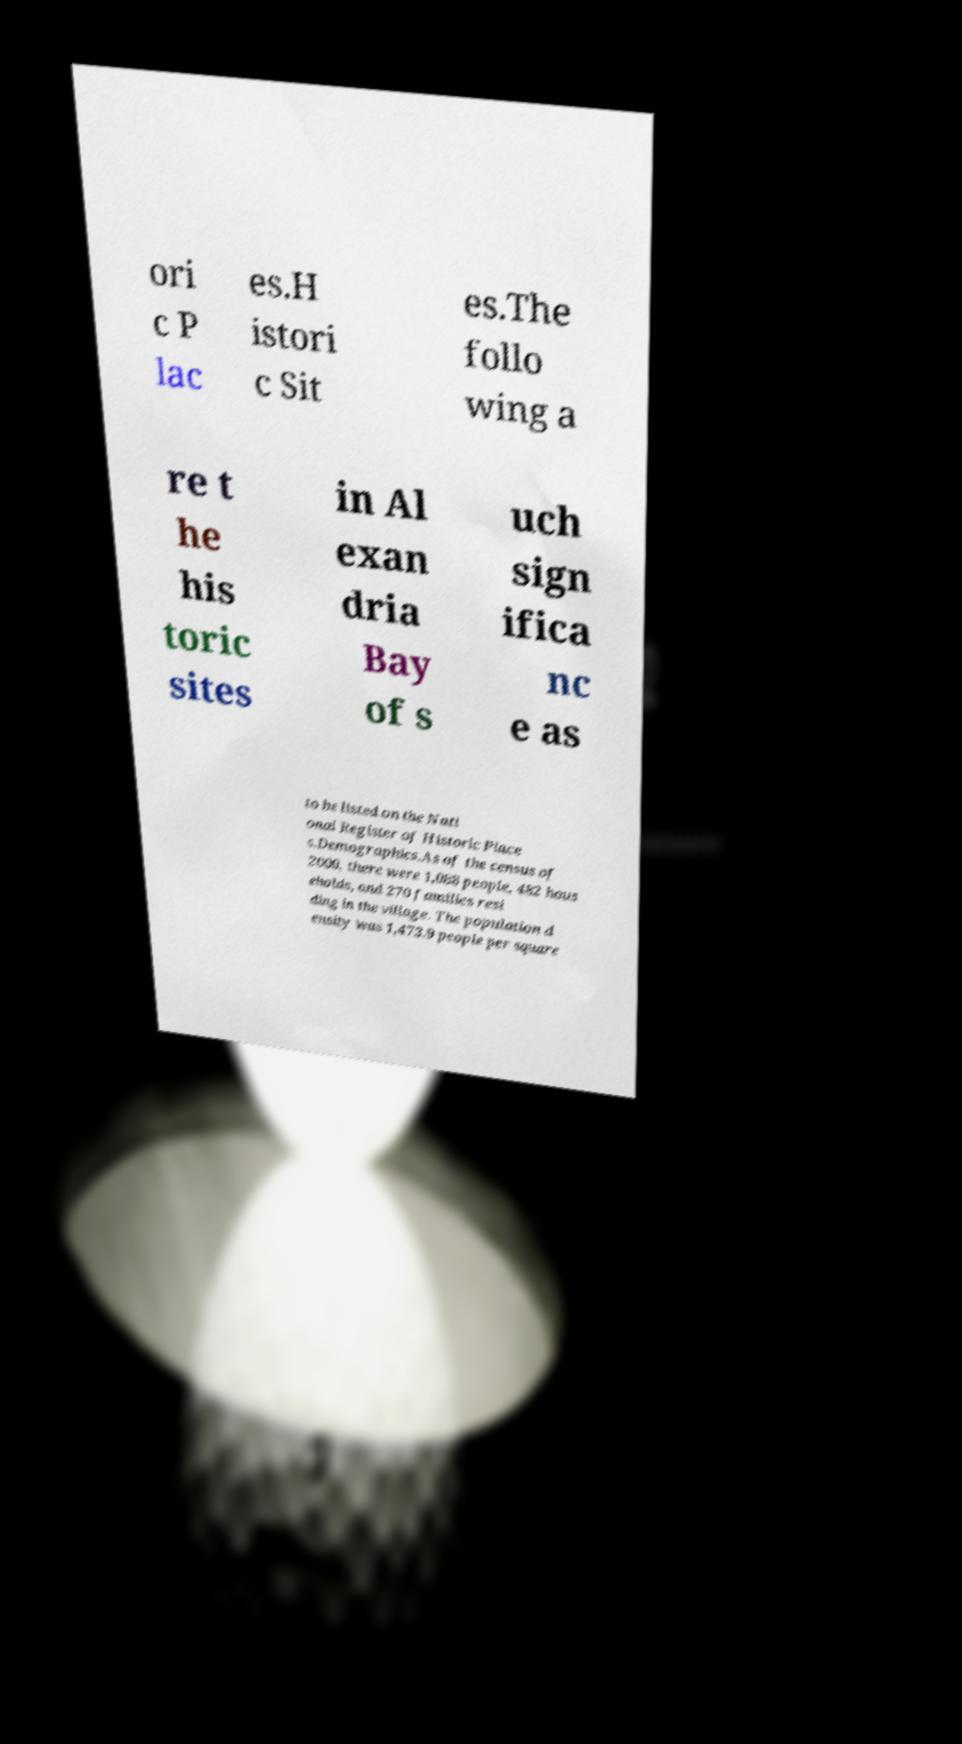Please read and relay the text visible in this image. What does it say? ori c P lac es.H istori c Sit es.The follo wing a re t he his toric sites in Al exan dria Bay of s uch sign ifica nc e as to be listed on the Nati onal Register of Historic Place s.Demographics.As of the census of 2000, there were 1,088 people, 482 hous eholds, and 270 families resi ding in the village. The population d ensity was 1,473.9 people per square 